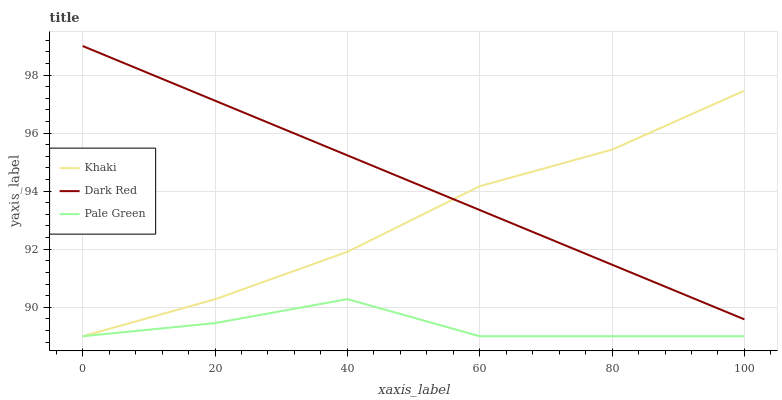Does Pale Green have the minimum area under the curve?
Answer yes or no. Yes. Does Dark Red have the maximum area under the curve?
Answer yes or no. Yes. Does Khaki have the minimum area under the curve?
Answer yes or no. No. Does Khaki have the maximum area under the curve?
Answer yes or no. No. Is Dark Red the smoothest?
Answer yes or no. Yes. Is Pale Green the roughest?
Answer yes or no. Yes. Is Khaki the smoothest?
Answer yes or no. No. Is Khaki the roughest?
Answer yes or no. No. Does Pale Green have the lowest value?
Answer yes or no. Yes. Does Dark Red have the highest value?
Answer yes or no. Yes. Does Khaki have the highest value?
Answer yes or no. No. Is Pale Green less than Dark Red?
Answer yes or no. Yes. Is Dark Red greater than Pale Green?
Answer yes or no. Yes. Does Pale Green intersect Khaki?
Answer yes or no. Yes. Is Pale Green less than Khaki?
Answer yes or no. No. Is Pale Green greater than Khaki?
Answer yes or no. No. Does Pale Green intersect Dark Red?
Answer yes or no. No. 